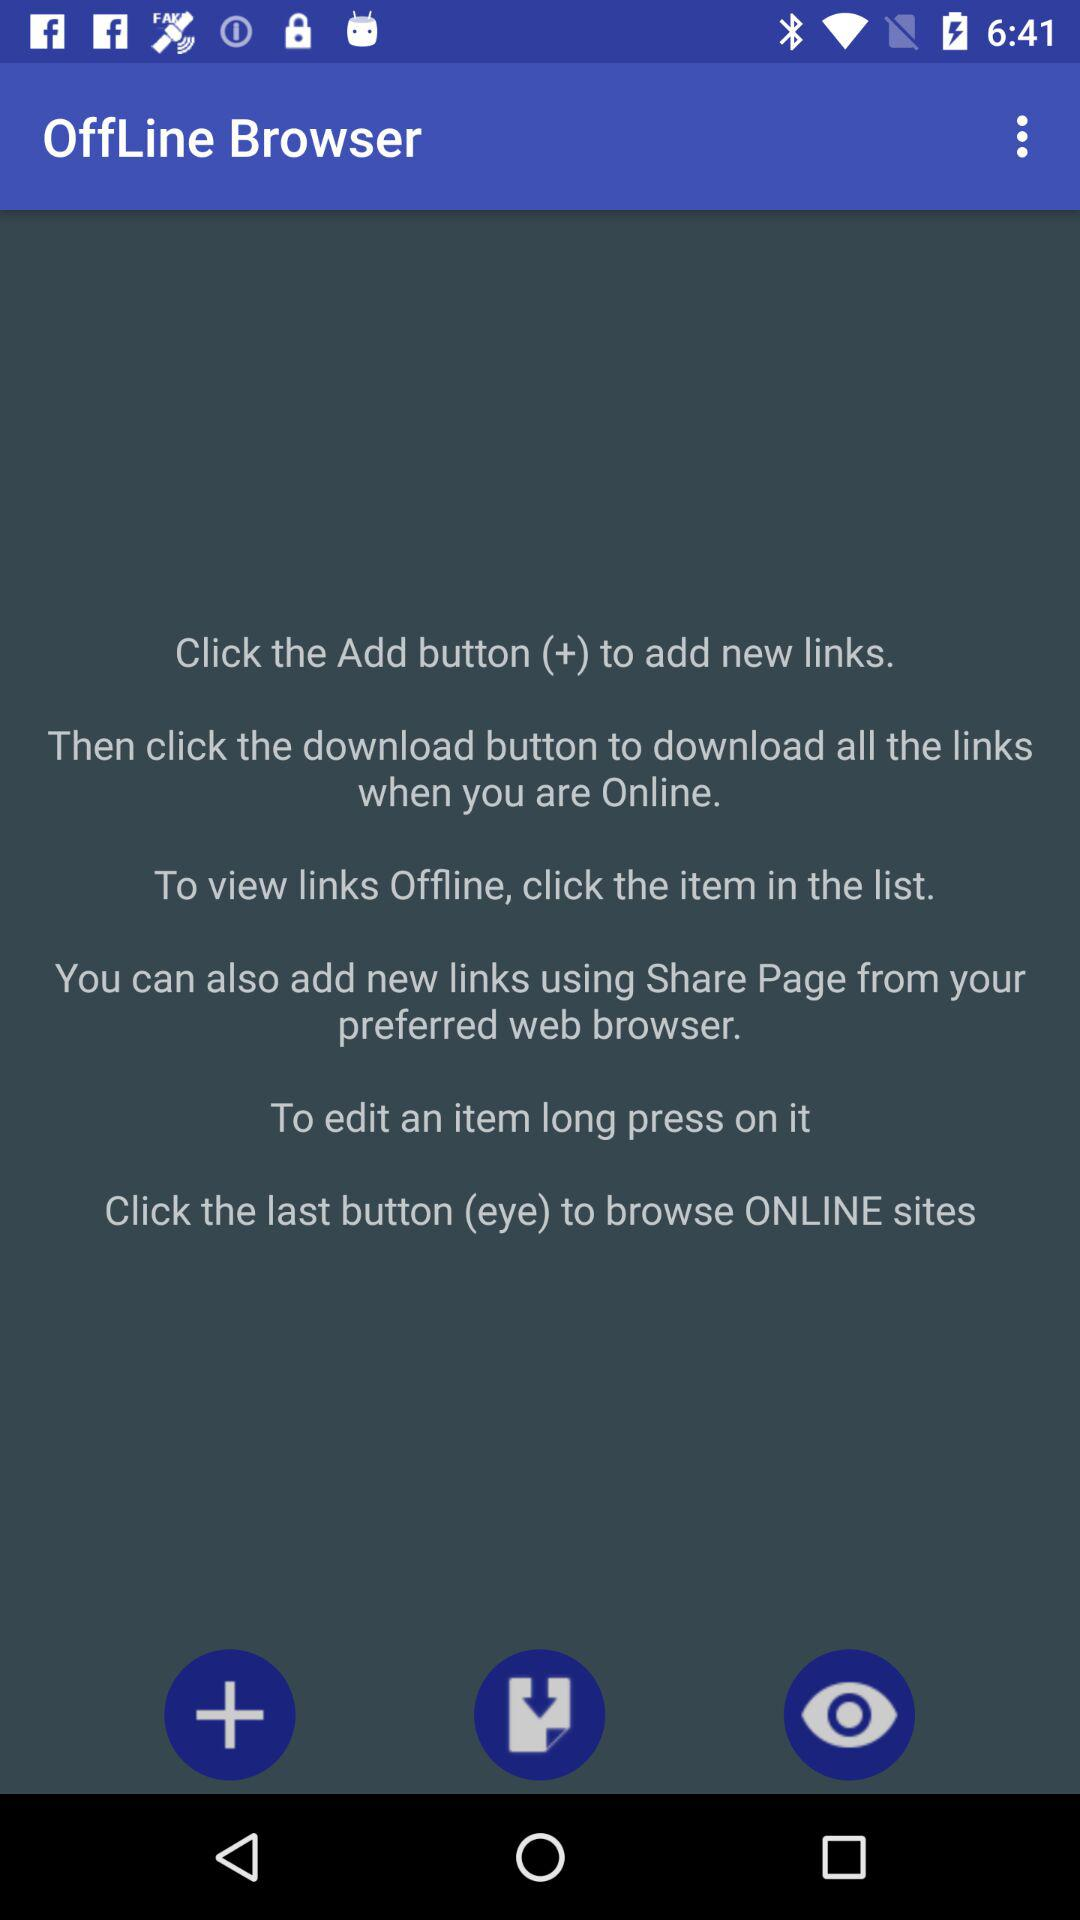What is the app name? The app name is "OffLine Browser". 